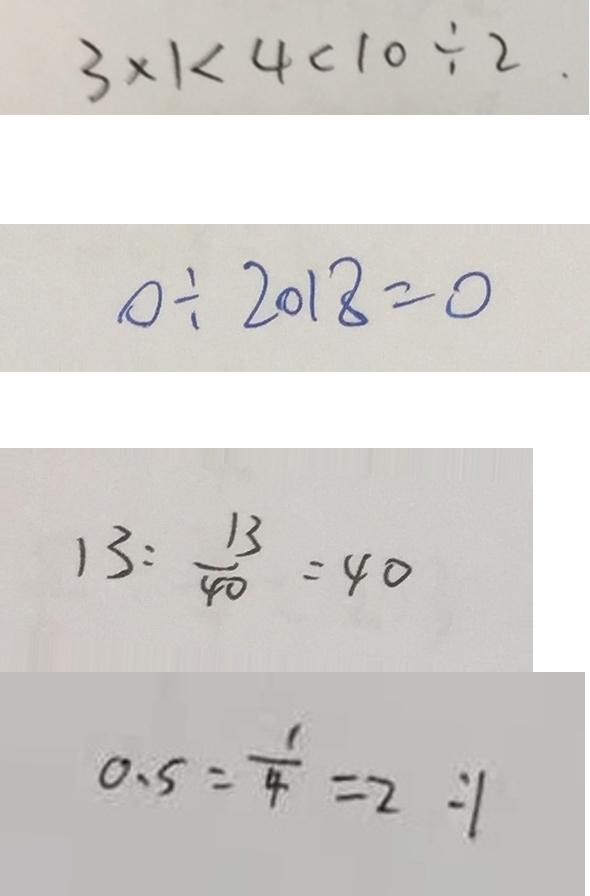<formula> <loc_0><loc_0><loc_500><loc_500>3 \times 1 < 4 < 1 0 \div 2 . 
 0 \div 2 0 1 8 = 0 
 1 3 : \frac { 1 3 } { 4 0 } = 4 0 
 0 . 5 : \frac { 1 } { 4 } = 2 : 1</formula> 